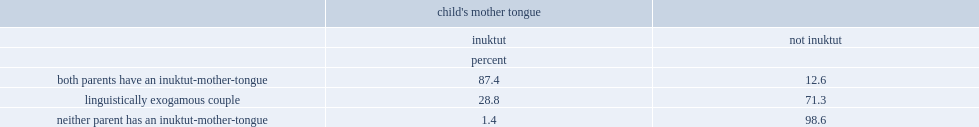Inuktut is transmitted as a mother tongue, what was the percent of children aged 0 to 17 years living in a two-parent household where both parents have an inuktut-mother-tongue? 87.4. What was the percent of children of linguistically exogamous couples? 28.8. What was the percent of children of couples where neither parent has inuktut as a mother tongue? 1.4. 